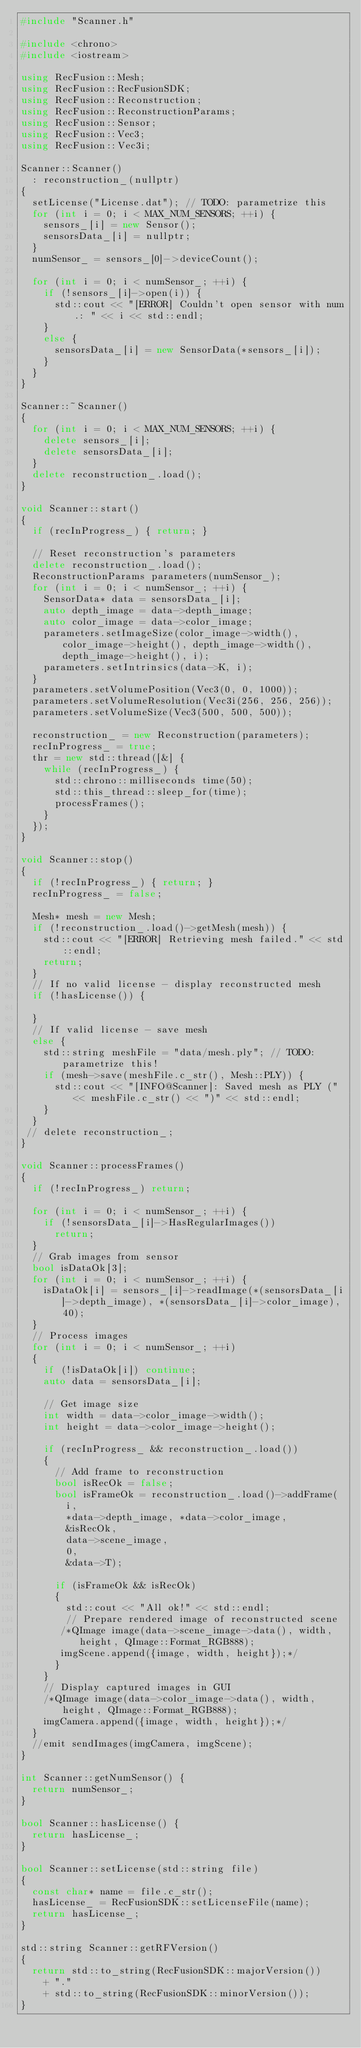<code> <loc_0><loc_0><loc_500><loc_500><_C++_>#include "Scanner.h"

#include <chrono>
#include <iostream>

using RecFusion::Mesh;
using RecFusion::RecFusionSDK;
using RecFusion::Reconstruction;
using RecFusion::ReconstructionParams;
using RecFusion::Sensor;
using RecFusion::Vec3;
using RecFusion::Vec3i;

Scanner::Scanner()
  : reconstruction_(nullptr)
{
  setLicense("License.dat"); // TODO: parametrize this
  for (int i = 0; i < MAX_NUM_SENSORS; ++i) {
    sensors_[i] = new Sensor();
    sensorsData_[i] = nullptr;
  }
  numSensor_ = sensors_[0]->deviceCount();

  for (int i = 0; i < numSensor_; ++i) {
    if (!sensors_[i]->open(i)) {
      std::cout << "[ERROR] Couldn't open sensor with num.: " << i << std::endl;
    }
    else {
      sensorsData_[i] = new SensorData(*sensors_[i]);
    }
  }
}

Scanner::~Scanner()
{
  for (int i = 0; i < MAX_NUM_SENSORS; ++i) {
    delete sensors_[i];
    delete sensorsData_[i];
  }
  delete reconstruction_.load();
}

void Scanner::start()
{
  if (recInProgress_) { return; }

  // Reset reconstruction's parameters
  delete reconstruction_.load();
  ReconstructionParams parameters(numSensor_);
  for (int i = 0; i < numSensor_; ++i) {
    SensorData* data = sensorsData_[i];
    auto depth_image = data->depth_image;
    auto color_image = data->color_image;
    parameters.setImageSize(color_image->width(), color_image->height(), depth_image->width(), depth_image->height(), i);
    parameters.setIntrinsics(data->K, i);
  }
  parameters.setVolumePosition(Vec3(0, 0, 1000));
  parameters.setVolumeResolution(Vec3i(256, 256, 256));
  parameters.setVolumeSize(Vec3(500, 500, 500));

  reconstruction_ = new Reconstruction(parameters);
  recInProgress_ = true;
  thr = new std::thread([&] {
    while (recInProgress_) {
      std::chrono::milliseconds time(50);
      std::this_thread::sleep_for(time);
      processFrames();
    }
  });
}

void Scanner::stop()
{
  if (!recInProgress_) { return; }
  recInProgress_ = false;

  Mesh* mesh = new Mesh;
  if (!reconstruction_.load()->getMesh(mesh)) {
    std::cout << "[ERROR] Retrieving mesh failed." << std::endl;
    return;
  }
  // If no valid license - display reconstructed mesh
  if (!hasLicense()) {

  }
  // If valid license - save mesh
  else {
    std::string meshFile = "data/mesh.ply"; // TODO: parametrize this!
    if (mesh->save(meshFile.c_str(), Mesh::PLY)) {
      std::cout << "[INFO@Scanner]: Saved mesh as PLY (" << meshFile.c_str() << ")" << std::endl;
    }
  }
 // delete reconstruction_;
}

void Scanner::processFrames()
{
  if (!recInProgress_) return;

  for (int i = 0; i < numSensor_; ++i) {
    if (!sensorsData_[i]->HasRegularImages())
      return;
  }
  // Grab images from sensor
  bool isDataOk[3];
  for (int i = 0; i < numSensor_; ++i) {
    isDataOk[i] = sensors_[i]->readImage(*(sensorsData_[i]->depth_image), *(sensorsData_[i]->color_image), 40);
  }
  // Process images
  for (int i = 0; i < numSensor_; ++i)
  {
    if (!isDataOk[i]) continue;
    auto data = sensorsData_[i];

    // Get image size
    int width = data->color_image->width();
    int height = data->color_image->height();

    if (recInProgress_ && reconstruction_.load())
    {
      // Add frame to reconstruction
      bool isRecOk = false;
      bool isFrameOk = reconstruction_.load()->addFrame(
        i,
        *data->depth_image, *data->color_image,
        &isRecOk,
        data->scene_image,
        0,
        &data->T);

      if (isFrameOk && isRecOk)
      {
        std::cout << "All ok!" << std::endl;
        // Prepare rendered image of reconstructed scene
       /*QImage image(data->scene_image->data(), width, height, QImage::Format_RGB888);
       imgScene.append({image, width, height});*/
      }
    }
    // Display captured images in GUI
    /*QImage image(data->color_image->data(), width, height, QImage::Format_RGB888);
    imgCamera.append({image, width, height});*/
  }
  //emit sendImages(imgCamera, imgScene);
}

int Scanner::getNumSensor() {
  return numSensor_;
}

bool Scanner::hasLicense() {
  return hasLicense_;
}

bool Scanner::setLicense(std::string file)
{
  const char* name = file.c_str();
  hasLicense_ = RecFusionSDK::setLicenseFile(name);
  return hasLicense_;
}

std::string Scanner::getRFVersion()
{
  return std::to_string(RecFusionSDK::majorVersion())
    + "."
    + std::to_string(RecFusionSDK::minorVersion());
}
</code> 